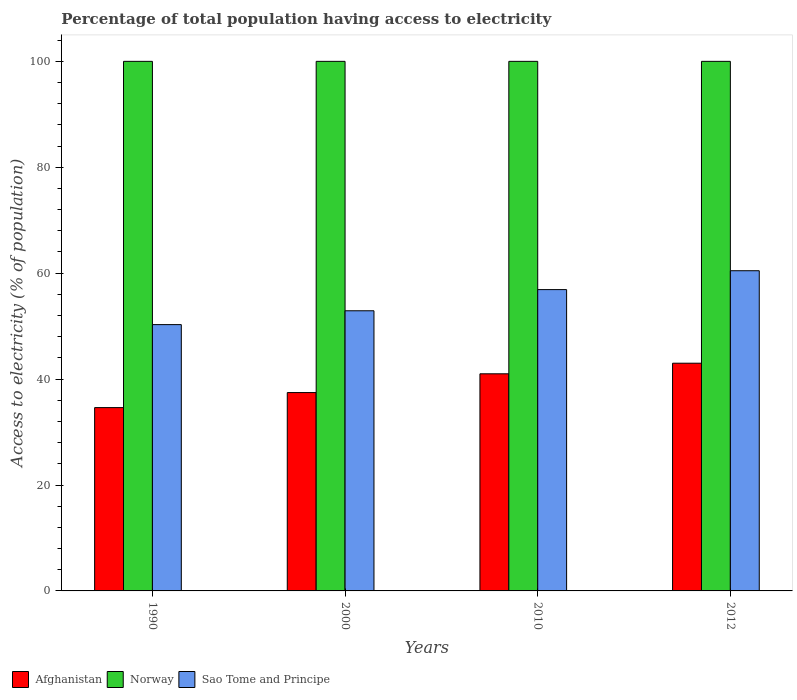How many different coloured bars are there?
Provide a succinct answer. 3. Are the number of bars per tick equal to the number of legend labels?
Offer a terse response. Yes. Are the number of bars on each tick of the X-axis equal?
Offer a very short reply. Yes. How many bars are there on the 3rd tick from the left?
Make the answer very short. 3. How many bars are there on the 3rd tick from the right?
Your answer should be compact. 3. What is the percentage of population that have access to electricity in Afghanistan in 1990?
Your answer should be compact. 34.62. Across all years, what is the maximum percentage of population that have access to electricity in Afghanistan?
Your answer should be very brief. 43. Across all years, what is the minimum percentage of population that have access to electricity in Norway?
Provide a succinct answer. 100. What is the total percentage of population that have access to electricity in Sao Tome and Principe in the graph?
Ensure brevity in your answer.  220.55. What is the difference between the percentage of population that have access to electricity in Sao Tome and Principe in 2010 and that in 2012?
Provide a short and direct response. -3.56. What is the difference between the percentage of population that have access to electricity in Norway in 2010 and the percentage of population that have access to electricity in Afghanistan in 2012?
Your answer should be very brief. 57. What is the average percentage of population that have access to electricity in Afghanistan per year?
Your response must be concise. 39.02. In the year 2010, what is the difference between the percentage of population that have access to electricity in Norway and percentage of population that have access to electricity in Sao Tome and Principe?
Ensure brevity in your answer.  43.1. What is the ratio of the percentage of population that have access to electricity in Afghanistan in 2000 to that in 2012?
Your answer should be very brief. 0.87. Is the percentage of population that have access to electricity in Sao Tome and Principe in 2000 less than that in 2012?
Provide a short and direct response. Yes. Is the difference between the percentage of population that have access to electricity in Norway in 2010 and 2012 greater than the difference between the percentage of population that have access to electricity in Sao Tome and Principe in 2010 and 2012?
Provide a short and direct response. Yes. What is the difference between the highest and the second highest percentage of population that have access to electricity in Afghanistan?
Keep it short and to the point. 2. Is the sum of the percentage of population that have access to electricity in Sao Tome and Principe in 1990 and 2012 greater than the maximum percentage of population that have access to electricity in Afghanistan across all years?
Give a very brief answer. Yes. What does the 2nd bar from the left in 1990 represents?
Keep it short and to the point. Norway. What does the 1st bar from the right in 2010 represents?
Ensure brevity in your answer.  Sao Tome and Principe. Are all the bars in the graph horizontal?
Provide a succinct answer. No. How many years are there in the graph?
Provide a succinct answer. 4. Does the graph contain any zero values?
Keep it short and to the point. No. Does the graph contain grids?
Your response must be concise. No. How many legend labels are there?
Provide a succinct answer. 3. How are the legend labels stacked?
Keep it short and to the point. Horizontal. What is the title of the graph?
Provide a short and direct response. Percentage of total population having access to electricity. What is the label or title of the X-axis?
Make the answer very short. Years. What is the label or title of the Y-axis?
Ensure brevity in your answer.  Access to electricity (% of population). What is the Access to electricity (% of population) of Afghanistan in 1990?
Make the answer very short. 34.62. What is the Access to electricity (% of population) of Norway in 1990?
Your answer should be compact. 100. What is the Access to electricity (% of population) of Sao Tome and Principe in 1990?
Offer a very short reply. 50.29. What is the Access to electricity (% of population) of Afghanistan in 2000?
Give a very brief answer. 37.46. What is the Access to electricity (% of population) of Norway in 2000?
Make the answer very short. 100. What is the Access to electricity (% of population) of Sao Tome and Principe in 2000?
Ensure brevity in your answer.  52.9. What is the Access to electricity (% of population) of Afghanistan in 2010?
Provide a short and direct response. 41. What is the Access to electricity (% of population) in Sao Tome and Principe in 2010?
Offer a terse response. 56.9. What is the Access to electricity (% of population) in Afghanistan in 2012?
Offer a terse response. 43. What is the Access to electricity (% of population) of Norway in 2012?
Give a very brief answer. 100. What is the Access to electricity (% of population) of Sao Tome and Principe in 2012?
Offer a very short reply. 60.46. Across all years, what is the maximum Access to electricity (% of population) of Afghanistan?
Offer a very short reply. 43. Across all years, what is the maximum Access to electricity (% of population) in Sao Tome and Principe?
Make the answer very short. 60.46. Across all years, what is the minimum Access to electricity (% of population) in Afghanistan?
Your answer should be compact. 34.62. Across all years, what is the minimum Access to electricity (% of population) in Sao Tome and Principe?
Your response must be concise. 50.29. What is the total Access to electricity (% of population) in Afghanistan in the graph?
Your response must be concise. 156.07. What is the total Access to electricity (% of population) of Sao Tome and Principe in the graph?
Your answer should be compact. 220.55. What is the difference between the Access to electricity (% of population) in Afghanistan in 1990 and that in 2000?
Provide a short and direct response. -2.84. What is the difference between the Access to electricity (% of population) in Sao Tome and Principe in 1990 and that in 2000?
Keep it short and to the point. -2.61. What is the difference between the Access to electricity (% of population) in Afghanistan in 1990 and that in 2010?
Your response must be concise. -6.38. What is the difference between the Access to electricity (% of population) of Norway in 1990 and that in 2010?
Provide a short and direct response. 0. What is the difference between the Access to electricity (% of population) in Sao Tome and Principe in 1990 and that in 2010?
Make the answer very short. -6.61. What is the difference between the Access to electricity (% of population) of Afghanistan in 1990 and that in 2012?
Ensure brevity in your answer.  -8.38. What is the difference between the Access to electricity (% of population) in Sao Tome and Principe in 1990 and that in 2012?
Offer a very short reply. -10.17. What is the difference between the Access to electricity (% of population) in Afghanistan in 2000 and that in 2010?
Your answer should be very brief. -3.54. What is the difference between the Access to electricity (% of population) of Sao Tome and Principe in 2000 and that in 2010?
Offer a terse response. -4. What is the difference between the Access to electricity (% of population) of Afghanistan in 2000 and that in 2012?
Keep it short and to the point. -5.54. What is the difference between the Access to electricity (% of population) in Sao Tome and Principe in 2000 and that in 2012?
Keep it short and to the point. -7.56. What is the difference between the Access to electricity (% of population) in Norway in 2010 and that in 2012?
Give a very brief answer. 0. What is the difference between the Access to electricity (% of population) of Sao Tome and Principe in 2010 and that in 2012?
Offer a very short reply. -3.56. What is the difference between the Access to electricity (% of population) in Afghanistan in 1990 and the Access to electricity (% of population) in Norway in 2000?
Provide a short and direct response. -65.38. What is the difference between the Access to electricity (% of population) of Afghanistan in 1990 and the Access to electricity (% of population) of Sao Tome and Principe in 2000?
Offer a very short reply. -18.28. What is the difference between the Access to electricity (% of population) in Norway in 1990 and the Access to electricity (% of population) in Sao Tome and Principe in 2000?
Ensure brevity in your answer.  47.1. What is the difference between the Access to electricity (% of population) of Afghanistan in 1990 and the Access to electricity (% of population) of Norway in 2010?
Make the answer very short. -65.38. What is the difference between the Access to electricity (% of population) in Afghanistan in 1990 and the Access to electricity (% of population) in Sao Tome and Principe in 2010?
Offer a very short reply. -22.28. What is the difference between the Access to electricity (% of population) of Norway in 1990 and the Access to electricity (% of population) of Sao Tome and Principe in 2010?
Your answer should be compact. 43.1. What is the difference between the Access to electricity (% of population) in Afghanistan in 1990 and the Access to electricity (% of population) in Norway in 2012?
Give a very brief answer. -65.38. What is the difference between the Access to electricity (% of population) in Afghanistan in 1990 and the Access to electricity (% of population) in Sao Tome and Principe in 2012?
Your answer should be compact. -25.85. What is the difference between the Access to electricity (% of population) in Norway in 1990 and the Access to electricity (% of population) in Sao Tome and Principe in 2012?
Provide a succinct answer. 39.54. What is the difference between the Access to electricity (% of population) of Afghanistan in 2000 and the Access to electricity (% of population) of Norway in 2010?
Offer a terse response. -62.54. What is the difference between the Access to electricity (% of population) in Afghanistan in 2000 and the Access to electricity (% of population) in Sao Tome and Principe in 2010?
Ensure brevity in your answer.  -19.44. What is the difference between the Access to electricity (% of population) of Norway in 2000 and the Access to electricity (% of population) of Sao Tome and Principe in 2010?
Make the answer very short. 43.1. What is the difference between the Access to electricity (% of population) of Afghanistan in 2000 and the Access to electricity (% of population) of Norway in 2012?
Make the answer very short. -62.54. What is the difference between the Access to electricity (% of population) of Afghanistan in 2000 and the Access to electricity (% of population) of Sao Tome and Principe in 2012?
Your answer should be compact. -23.01. What is the difference between the Access to electricity (% of population) in Norway in 2000 and the Access to electricity (% of population) in Sao Tome and Principe in 2012?
Give a very brief answer. 39.54. What is the difference between the Access to electricity (% of population) of Afghanistan in 2010 and the Access to electricity (% of population) of Norway in 2012?
Make the answer very short. -59. What is the difference between the Access to electricity (% of population) in Afghanistan in 2010 and the Access to electricity (% of population) in Sao Tome and Principe in 2012?
Give a very brief answer. -19.46. What is the difference between the Access to electricity (% of population) of Norway in 2010 and the Access to electricity (% of population) of Sao Tome and Principe in 2012?
Offer a terse response. 39.54. What is the average Access to electricity (% of population) of Afghanistan per year?
Provide a succinct answer. 39.02. What is the average Access to electricity (% of population) in Sao Tome and Principe per year?
Provide a succinct answer. 55.14. In the year 1990, what is the difference between the Access to electricity (% of population) in Afghanistan and Access to electricity (% of population) in Norway?
Your answer should be very brief. -65.38. In the year 1990, what is the difference between the Access to electricity (% of population) in Afghanistan and Access to electricity (% of population) in Sao Tome and Principe?
Ensure brevity in your answer.  -15.67. In the year 1990, what is the difference between the Access to electricity (% of population) in Norway and Access to electricity (% of population) in Sao Tome and Principe?
Your response must be concise. 49.71. In the year 2000, what is the difference between the Access to electricity (% of population) of Afghanistan and Access to electricity (% of population) of Norway?
Provide a succinct answer. -62.54. In the year 2000, what is the difference between the Access to electricity (% of population) in Afghanistan and Access to electricity (% of population) in Sao Tome and Principe?
Give a very brief answer. -15.44. In the year 2000, what is the difference between the Access to electricity (% of population) in Norway and Access to electricity (% of population) in Sao Tome and Principe?
Your response must be concise. 47.1. In the year 2010, what is the difference between the Access to electricity (% of population) of Afghanistan and Access to electricity (% of population) of Norway?
Your answer should be very brief. -59. In the year 2010, what is the difference between the Access to electricity (% of population) of Afghanistan and Access to electricity (% of population) of Sao Tome and Principe?
Your answer should be very brief. -15.9. In the year 2010, what is the difference between the Access to electricity (% of population) in Norway and Access to electricity (% of population) in Sao Tome and Principe?
Your response must be concise. 43.1. In the year 2012, what is the difference between the Access to electricity (% of population) of Afghanistan and Access to electricity (% of population) of Norway?
Provide a succinct answer. -57. In the year 2012, what is the difference between the Access to electricity (% of population) in Afghanistan and Access to electricity (% of population) in Sao Tome and Principe?
Make the answer very short. -17.46. In the year 2012, what is the difference between the Access to electricity (% of population) in Norway and Access to electricity (% of population) in Sao Tome and Principe?
Provide a succinct answer. 39.54. What is the ratio of the Access to electricity (% of population) of Afghanistan in 1990 to that in 2000?
Keep it short and to the point. 0.92. What is the ratio of the Access to electricity (% of population) of Sao Tome and Principe in 1990 to that in 2000?
Ensure brevity in your answer.  0.95. What is the ratio of the Access to electricity (% of population) of Afghanistan in 1990 to that in 2010?
Provide a succinct answer. 0.84. What is the ratio of the Access to electricity (% of population) in Sao Tome and Principe in 1990 to that in 2010?
Your answer should be very brief. 0.88. What is the ratio of the Access to electricity (% of population) in Afghanistan in 1990 to that in 2012?
Give a very brief answer. 0.81. What is the ratio of the Access to electricity (% of population) in Norway in 1990 to that in 2012?
Keep it short and to the point. 1. What is the ratio of the Access to electricity (% of population) in Sao Tome and Principe in 1990 to that in 2012?
Provide a short and direct response. 0.83. What is the ratio of the Access to electricity (% of population) of Afghanistan in 2000 to that in 2010?
Make the answer very short. 0.91. What is the ratio of the Access to electricity (% of population) in Sao Tome and Principe in 2000 to that in 2010?
Offer a terse response. 0.93. What is the ratio of the Access to electricity (% of population) of Afghanistan in 2000 to that in 2012?
Provide a succinct answer. 0.87. What is the ratio of the Access to electricity (% of population) in Norway in 2000 to that in 2012?
Your response must be concise. 1. What is the ratio of the Access to electricity (% of population) of Sao Tome and Principe in 2000 to that in 2012?
Offer a terse response. 0.87. What is the ratio of the Access to electricity (% of population) in Afghanistan in 2010 to that in 2012?
Give a very brief answer. 0.95. What is the ratio of the Access to electricity (% of population) of Sao Tome and Principe in 2010 to that in 2012?
Make the answer very short. 0.94. What is the difference between the highest and the second highest Access to electricity (% of population) of Afghanistan?
Make the answer very short. 2. What is the difference between the highest and the second highest Access to electricity (% of population) of Sao Tome and Principe?
Ensure brevity in your answer.  3.56. What is the difference between the highest and the lowest Access to electricity (% of population) in Afghanistan?
Make the answer very short. 8.38. What is the difference between the highest and the lowest Access to electricity (% of population) of Norway?
Make the answer very short. 0. What is the difference between the highest and the lowest Access to electricity (% of population) of Sao Tome and Principe?
Give a very brief answer. 10.17. 